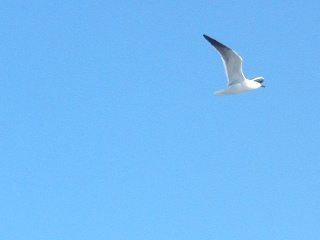Are there zebras in this image? No, there are no zebras in this image. It depicts a bird flying in a clear blue sky. 